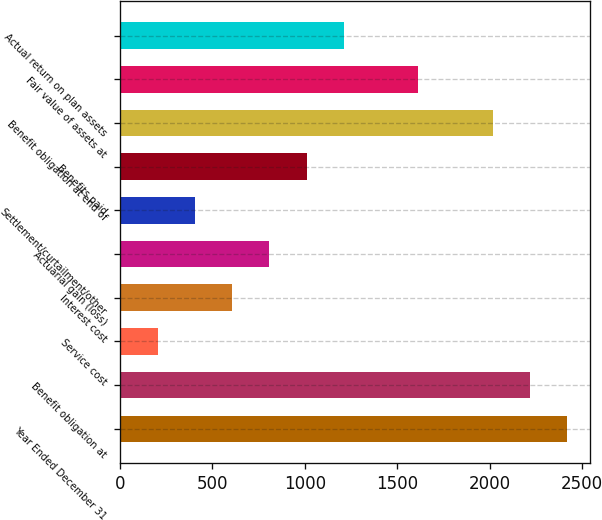<chart> <loc_0><loc_0><loc_500><loc_500><bar_chart><fcel>Year Ended December 31<fcel>Benefit obligation at<fcel>Service cost<fcel>Interest cost<fcel>Actuarial gain (loss)<fcel>Settlement/curtailment/other<fcel>Benefits paid<fcel>Benefit obligation at end of<fcel>Fair value of assets at<fcel>Actual return on plan assets<nl><fcel>2419.8<fcel>2218.4<fcel>204.4<fcel>607.2<fcel>808.6<fcel>405.8<fcel>1010<fcel>2017<fcel>1614.2<fcel>1211.4<nl></chart> 